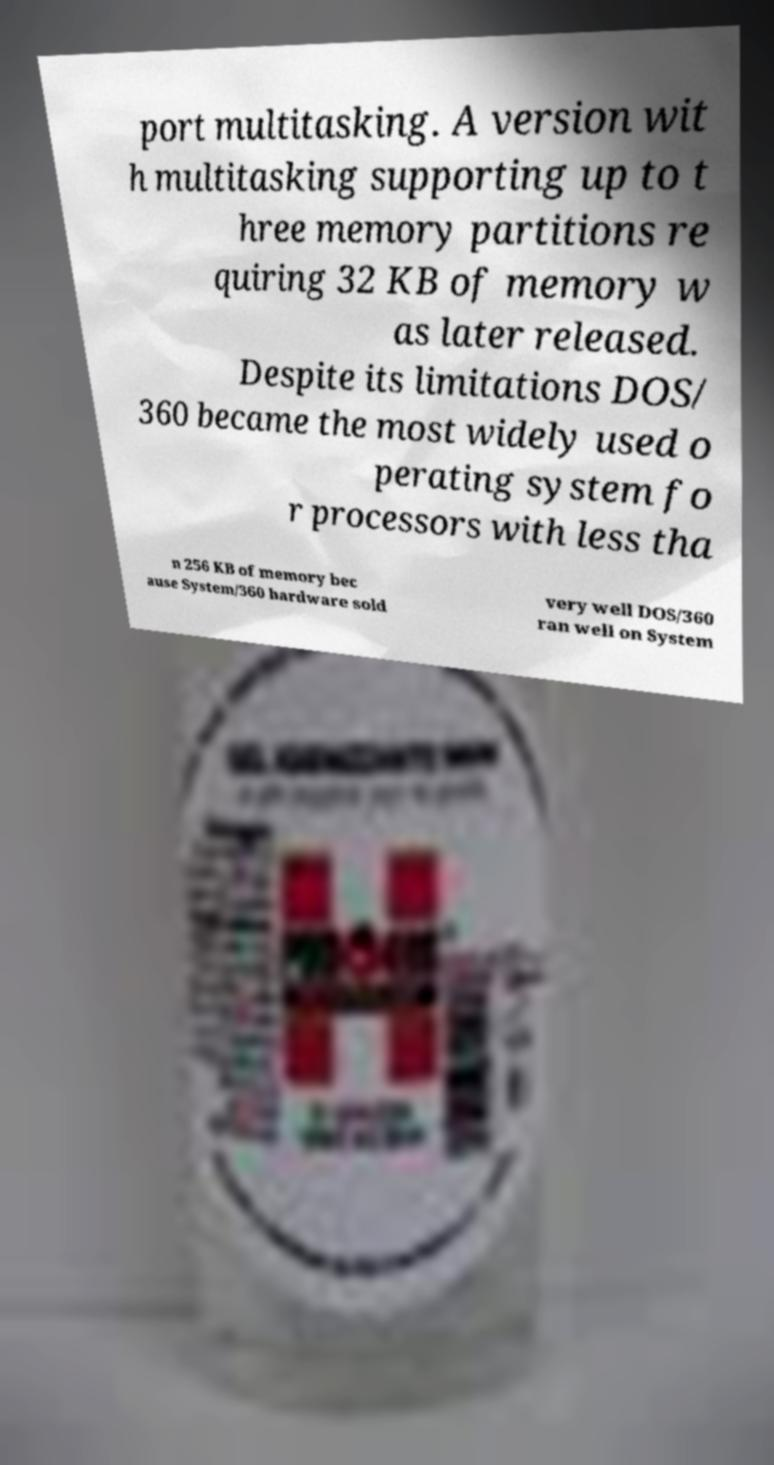Please identify and transcribe the text found in this image. port multitasking. A version wit h multitasking supporting up to t hree memory partitions re quiring 32 KB of memory w as later released. Despite its limitations DOS/ 360 became the most widely used o perating system fo r processors with less tha n 256 KB of memory bec ause System/360 hardware sold very well DOS/360 ran well on System 